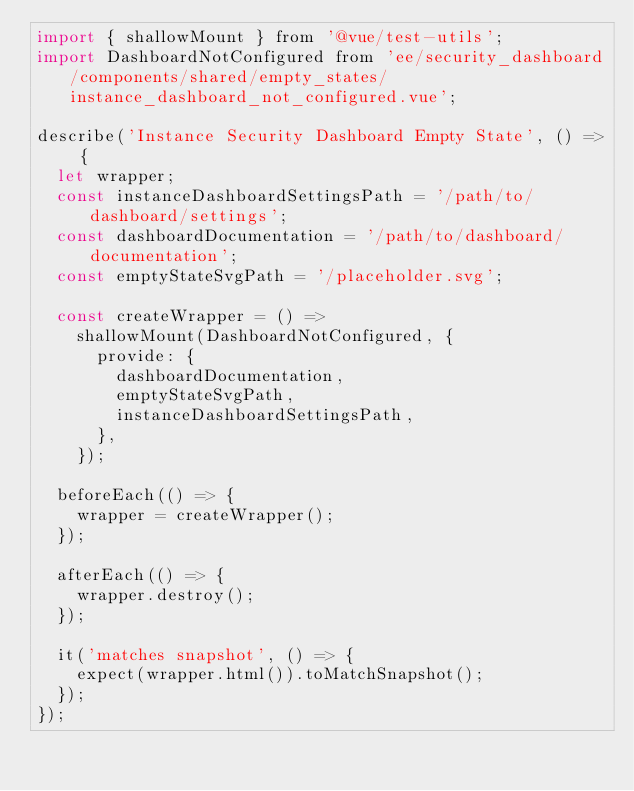Convert code to text. <code><loc_0><loc_0><loc_500><loc_500><_JavaScript_>import { shallowMount } from '@vue/test-utils';
import DashboardNotConfigured from 'ee/security_dashboard/components/shared/empty_states/instance_dashboard_not_configured.vue';

describe('Instance Security Dashboard Empty State', () => {
  let wrapper;
  const instanceDashboardSettingsPath = '/path/to/dashboard/settings';
  const dashboardDocumentation = '/path/to/dashboard/documentation';
  const emptyStateSvgPath = '/placeholder.svg';

  const createWrapper = () =>
    shallowMount(DashboardNotConfigured, {
      provide: {
        dashboardDocumentation,
        emptyStateSvgPath,
        instanceDashboardSettingsPath,
      },
    });

  beforeEach(() => {
    wrapper = createWrapper();
  });

  afterEach(() => {
    wrapper.destroy();
  });

  it('matches snapshot', () => {
    expect(wrapper.html()).toMatchSnapshot();
  });
});
</code> 